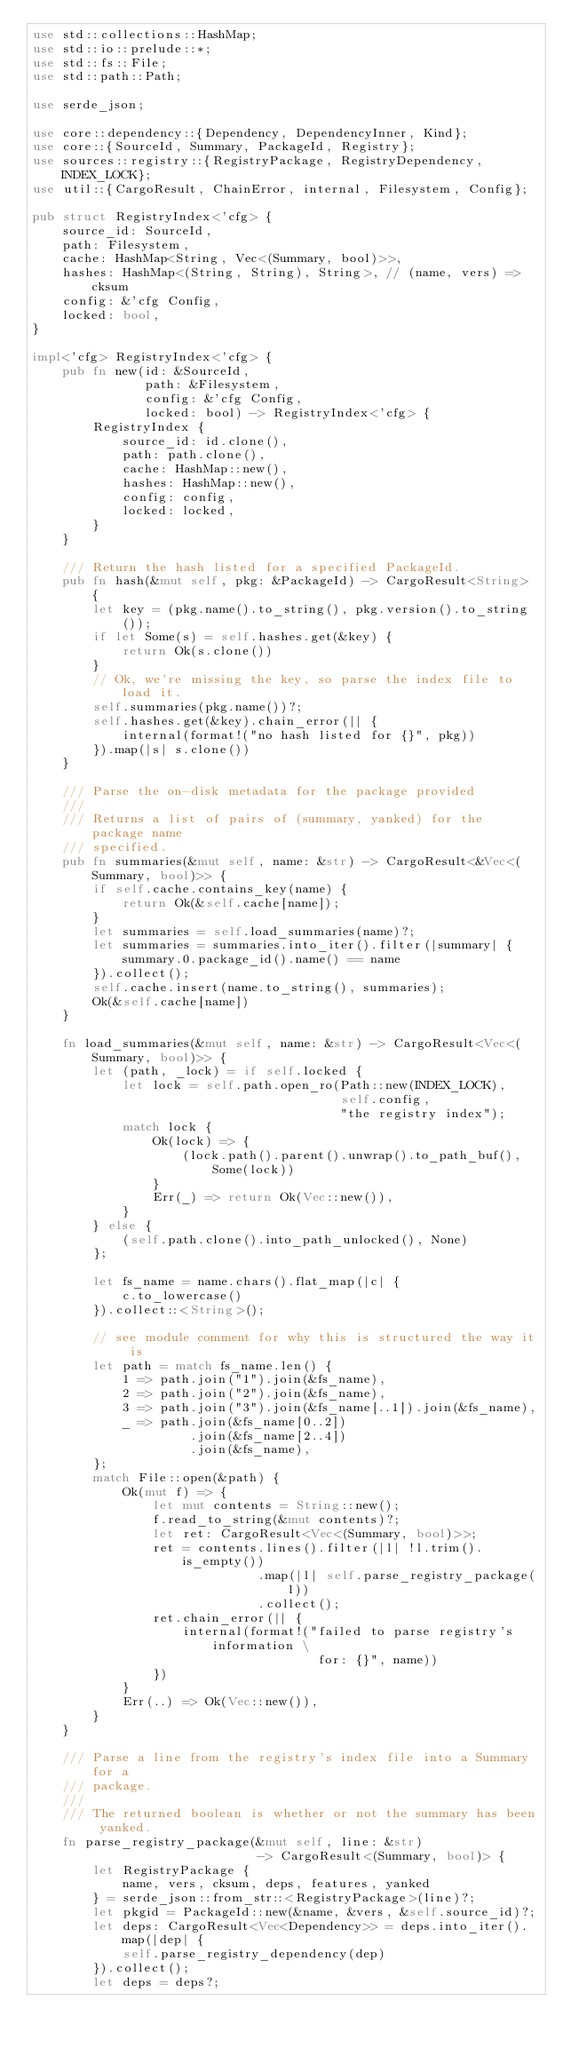Convert code to text. <code><loc_0><loc_0><loc_500><loc_500><_Rust_>use std::collections::HashMap;
use std::io::prelude::*;
use std::fs::File;
use std::path::Path;

use serde_json;

use core::dependency::{Dependency, DependencyInner, Kind};
use core::{SourceId, Summary, PackageId, Registry};
use sources::registry::{RegistryPackage, RegistryDependency, INDEX_LOCK};
use util::{CargoResult, ChainError, internal, Filesystem, Config};

pub struct RegistryIndex<'cfg> {
    source_id: SourceId,
    path: Filesystem,
    cache: HashMap<String, Vec<(Summary, bool)>>,
    hashes: HashMap<(String, String), String>, // (name, vers) => cksum
    config: &'cfg Config,
    locked: bool,
}

impl<'cfg> RegistryIndex<'cfg> {
    pub fn new(id: &SourceId,
               path: &Filesystem,
               config: &'cfg Config,
               locked: bool) -> RegistryIndex<'cfg> {
        RegistryIndex {
            source_id: id.clone(),
            path: path.clone(),
            cache: HashMap::new(),
            hashes: HashMap::new(),
            config: config,
            locked: locked,
        }
    }

    /// Return the hash listed for a specified PackageId.
    pub fn hash(&mut self, pkg: &PackageId) -> CargoResult<String> {
        let key = (pkg.name().to_string(), pkg.version().to_string());
        if let Some(s) = self.hashes.get(&key) {
            return Ok(s.clone())
        }
        // Ok, we're missing the key, so parse the index file to load it.
        self.summaries(pkg.name())?;
        self.hashes.get(&key).chain_error(|| {
            internal(format!("no hash listed for {}", pkg))
        }).map(|s| s.clone())
    }

    /// Parse the on-disk metadata for the package provided
    ///
    /// Returns a list of pairs of (summary, yanked) for the package name
    /// specified.
    pub fn summaries(&mut self, name: &str) -> CargoResult<&Vec<(Summary, bool)>> {
        if self.cache.contains_key(name) {
            return Ok(&self.cache[name]);
        }
        let summaries = self.load_summaries(name)?;
        let summaries = summaries.into_iter().filter(|summary| {
            summary.0.package_id().name() == name
        }).collect();
        self.cache.insert(name.to_string(), summaries);
        Ok(&self.cache[name])
    }

    fn load_summaries(&mut self, name: &str) -> CargoResult<Vec<(Summary, bool)>> {
        let (path, _lock) = if self.locked {
            let lock = self.path.open_ro(Path::new(INDEX_LOCK),
                                         self.config,
                                         "the registry index");
            match lock {
                Ok(lock) => {
                    (lock.path().parent().unwrap().to_path_buf(), Some(lock))
                }
                Err(_) => return Ok(Vec::new()),
            }
        } else {
            (self.path.clone().into_path_unlocked(), None)
        };

        let fs_name = name.chars().flat_map(|c| {
            c.to_lowercase()
        }).collect::<String>();

        // see module comment for why this is structured the way it is
        let path = match fs_name.len() {
            1 => path.join("1").join(&fs_name),
            2 => path.join("2").join(&fs_name),
            3 => path.join("3").join(&fs_name[..1]).join(&fs_name),
            _ => path.join(&fs_name[0..2])
                     .join(&fs_name[2..4])
                     .join(&fs_name),
        };
        match File::open(&path) {
            Ok(mut f) => {
                let mut contents = String::new();
                f.read_to_string(&mut contents)?;
                let ret: CargoResult<Vec<(Summary, bool)>>;
                ret = contents.lines().filter(|l| !l.trim().is_empty())
                              .map(|l| self.parse_registry_package(l))
                              .collect();
                ret.chain_error(|| {
                    internal(format!("failed to parse registry's information \
                                      for: {}", name))
                })
            }
            Err(..) => Ok(Vec::new()),
        }
    }

    /// Parse a line from the registry's index file into a Summary for a
    /// package.
    ///
    /// The returned boolean is whether or not the summary has been yanked.
    fn parse_registry_package(&mut self, line: &str)
                              -> CargoResult<(Summary, bool)> {
        let RegistryPackage {
            name, vers, cksum, deps, features, yanked
        } = serde_json::from_str::<RegistryPackage>(line)?;
        let pkgid = PackageId::new(&name, &vers, &self.source_id)?;
        let deps: CargoResult<Vec<Dependency>> = deps.into_iter().map(|dep| {
            self.parse_registry_dependency(dep)
        }).collect();
        let deps = deps?;</code> 